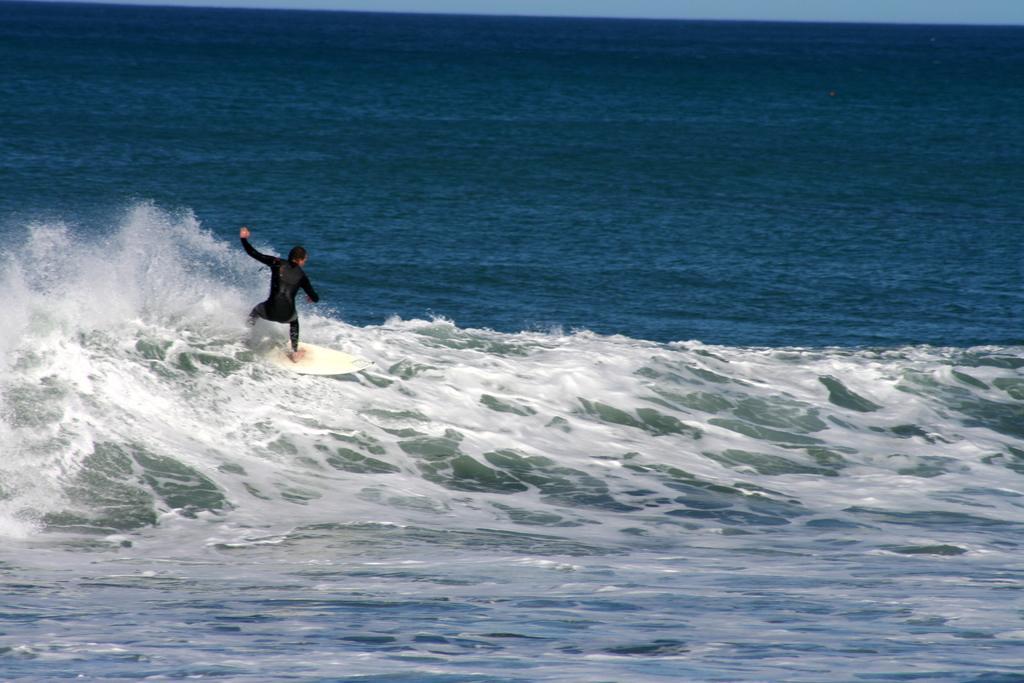Describe this image in one or two sentences. In this image I can see a person surfing in water using surfboard and the board is in white color, and the person is wearing black color dress. 